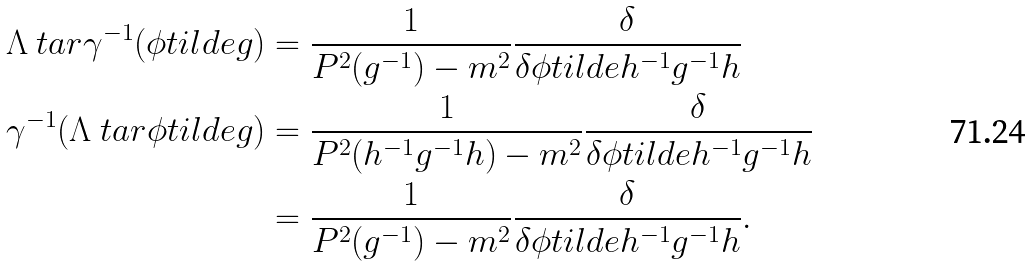<formula> <loc_0><loc_0><loc_500><loc_500>\Lambda \ t a r \gamma ^ { - 1 } ( \phi t i l d e { g } ) & = \frac { 1 } { P ^ { 2 } ( g ^ { - 1 } ) - m ^ { 2 } } \frac { \delta } { \delta \phi t i l d e { h ^ { - 1 } g ^ { - 1 } h } } \\ \gamma ^ { - 1 } ( \Lambda \ t a r \phi t i l d e { g } ) & = \frac { 1 } { P ^ { 2 } ( h ^ { - 1 } g ^ { - 1 } h ) - m ^ { 2 } } \frac { \delta } { \delta \phi t i l d e { h ^ { - 1 } g ^ { - 1 } h } } \\ & = \frac { 1 } { P ^ { 2 } ( g ^ { - 1 } ) - m ^ { 2 } } \frac { \delta } { \delta \phi t i l d e { h ^ { - 1 } g ^ { - 1 } h } } .</formula> 